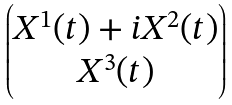Convert formula to latex. <formula><loc_0><loc_0><loc_500><loc_500>\begin{pmatrix} X ^ { 1 } ( t ) + i X ^ { 2 } ( t ) \\ X ^ { 3 } ( t ) \end{pmatrix}</formula> 